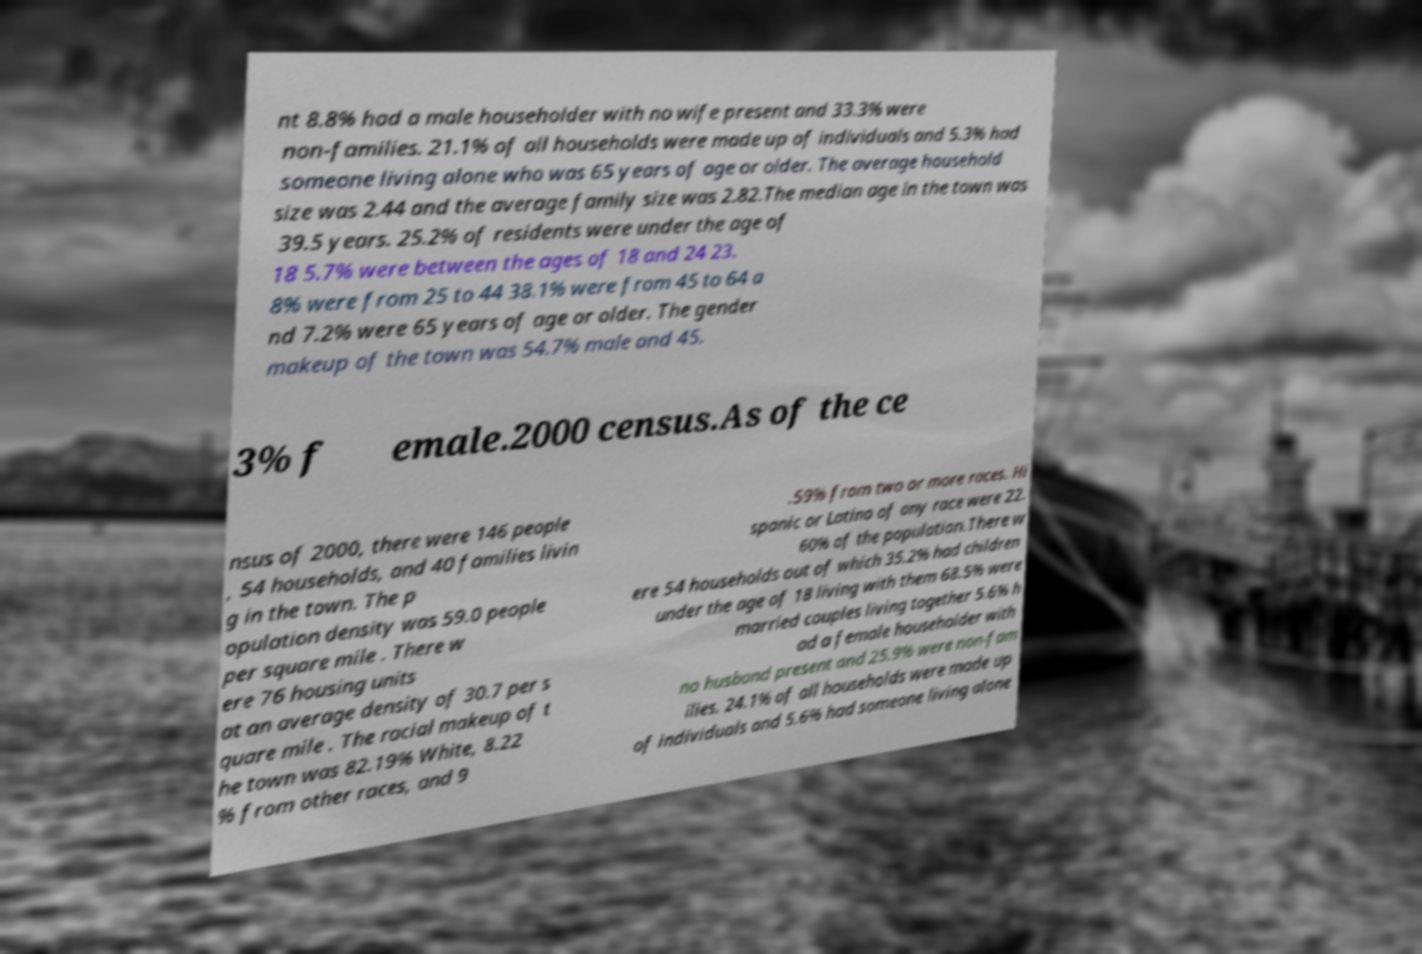Could you assist in decoding the text presented in this image and type it out clearly? nt 8.8% had a male householder with no wife present and 33.3% were non-families. 21.1% of all households were made up of individuals and 5.3% had someone living alone who was 65 years of age or older. The average household size was 2.44 and the average family size was 2.82.The median age in the town was 39.5 years. 25.2% of residents were under the age of 18 5.7% were between the ages of 18 and 24 23. 8% were from 25 to 44 38.1% were from 45 to 64 a nd 7.2% were 65 years of age or older. The gender makeup of the town was 54.7% male and 45. 3% f emale.2000 census.As of the ce nsus of 2000, there were 146 people , 54 households, and 40 families livin g in the town. The p opulation density was 59.0 people per square mile . There w ere 76 housing units at an average density of 30.7 per s quare mile . The racial makeup of t he town was 82.19% White, 8.22 % from other races, and 9 .59% from two or more races. Hi spanic or Latino of any race were 22. 60% of the population.There w ere 54 households out of which 35.2% had children under the age of 18 living with them 68.5% were married couples living together 5.6% h ad a female householder with no husband present and 25.9% were non-fam ilies. 24.1% of all households were made up of individuals and 5.6% had someone living alone 